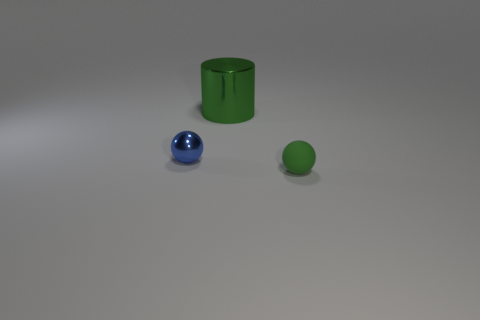Add 2 green matte spheres. How many objects exist? 5 Subtract all balls. How many objects are left? 1 Subtract 0 yellow spheres. How many objects are left? 3 Subtract all tiny brown blocks. Subtract all big things. How many objects are left? 2 Add 3 large green shiny things. How many large green shiny things are left? 4 Add 2 green matte things. How many green matte things exist? 3 